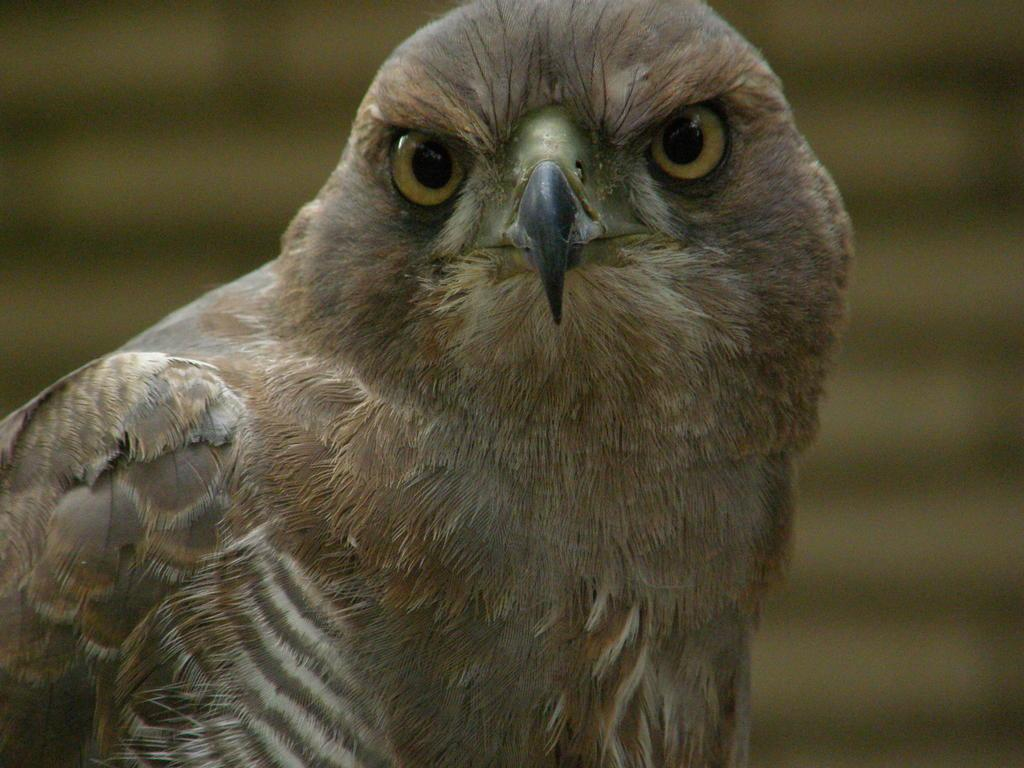What type of animal is in the image? There is a bird in the image. Can you describe the bird's coloring? The bird has brown, white, and black colors. What can be observed about the background of the image? The background of the image is blurred. How many cracks can be seen on the bird's beak in the image? There are no cracks visible on the bird's beak in the image, as the bird's beak is not shown in the image. 